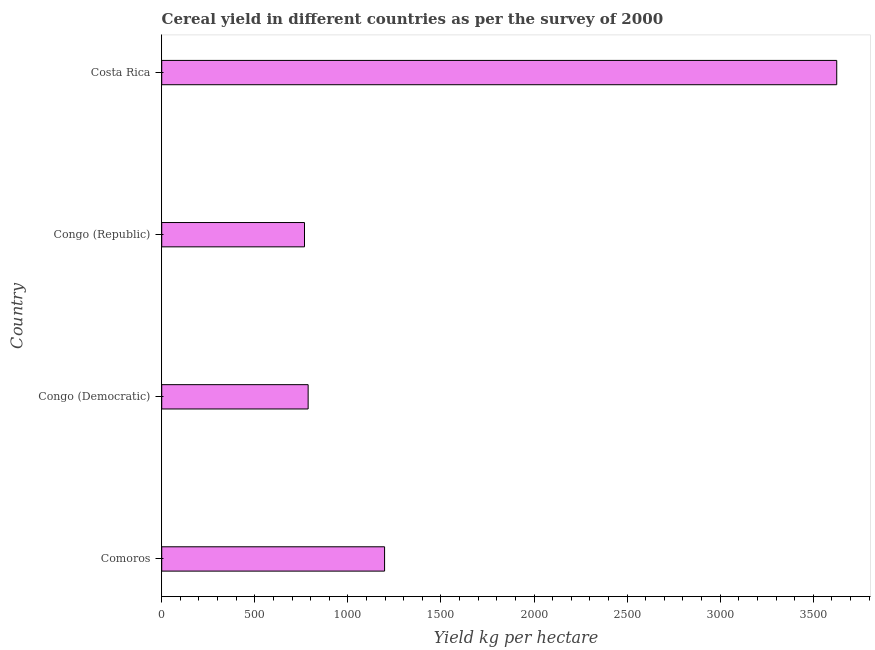Does the graph contain any zero values?
Give a very brief answer. No. What is the title of the graph?
Offer a very short reply. Cereal yield in different countries as per the survey of 2000. What is the label or title of the X-axis?
Offer a very short reply. Yield kg per hectare. What is the label or title of the Y-axis?
Provide a succinct answer. Country. What is the cereal yield in Congo (Democratic)?
Your response must be concise. 786.65. Across all countries, what is the maximum cereal yield?
Offer a terse response. 3626.21. Across all countries, what is the minimum cereal yield?
Offer a terse response. 767.03. In which country was the cereal yield maximum?
Give a very brief answer. Costa Rica. In which country was the cereal yield minimum?
Give a very brief answer. Congo (Republic). What is the sum of the cereal yield?
Keep it short and to the point. 6377.12. What is the difference between the cereal yield in Congo (Democratic) and Costa Rica?
Offer a very short reply. -2839.56. What is the average cereal yield per country?
Make the answer very short. 1594.28. What is the median cereal yield?
Your response must be concise. 991.94. In how many countries, is the cereal yield greater than 2200 kg per hectare?
Your answer should be very brief. 1. What is the ratio of the cereal yield in Congo (Democratic) to that in Costa Rica?
Offer a very short reply. 0.22. Is the cereal yield in Congo (Democratic) less than that in Congo (Republic)?
Your response must be concise. No. Is the difference between the cereal yield in Comoros and Costa Rica greater than the difference between any two countries?
Your answer should be very brief. No. What is the difference between the highest and the second highest cereal yield?
Offer a terse response. 2428.97. What is the difference between the highest and the lowest cereal yield?
Your response must be concise. 2859.18. Are all the bars in the graph horizontal?
Ensure brevity in your answer.  Yes. How many countries are there in the graph?
Ensure brevity in your answer.  4. What is the difference between two consecutive major ticks on the X-axis?
Ensure brevity in your answer.  500. Are the values on the major ticks of X-axis written in scientific E-notation?
Offer a very short reply. No. What is the Yield kg per hectare of Comoros?
Your answer should be compact. 1197.24. What is the Yield kg per hectare of Congo (Democratic)?
Your answer should be very brief. 786.65. What is the Yield kg per hectare in Congo (Republic)?
Provide a short and direct response. 767.03. What is the Yield kg per hectare of Costa Rica?
Your answer should be compact. 3626.21. What is the difference between the Yield kg per hectare in Comoros and Congo (Democratic)?
Offer a terse response. 410.59. What is the difference between the Yield kg per hectare in Comoros and Congo (Republic)?
Your answer should be very brief. 430.21. What is the difference between the Yield kg per hectare in Comoros and Costa Rica?
Make the answer very short. -2428.97. What is the difference between the Yield kg per hectare in Congo (Democratic) and Congo (Republic)?
Your answer should be very brief. 19.62. What is the difference between the Yield kg per hectare in Congo (Democratic) and Costa Rica?
Ensure brevity in your answer.  -2839.56. What is the difference between the Yield kg per hectare in Congo (Republic) and Costa Rica?
Give a very brief answer. -2859.18. What is the ratio of the Yield kg per hectare in Comoros to that in Congo (Democratic)?
Your response must be concise. 1.52. What is the ratio of the Yield kg per hectare in Comoros to that in Congo (Republic)?
Make the answer very short. 1.56. What is the ratio of the Yield kg per hectare in Comoros to that in Costa Rica?
Keep it short and to the point. 0.33. What is the ratio of the Yield kg per hectare in Congo (Democratic) to that in Costa Rica?
Provide a succinct answer. 0.22. What is the ratio of the Yield kg per hectare in Congo (Republic) to that in Costa Rica?
Offer a very short reply. 0.21. 